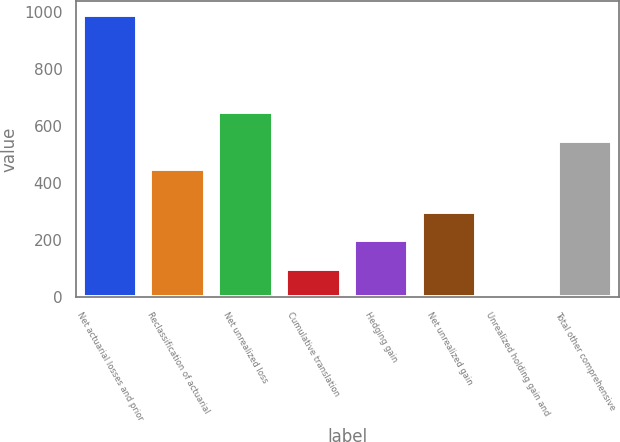Convert chart to OTSL. <chart><loc_0><loc_0><loc_500><loc_500><bar_chart><fcel>Net actuarial losses and prior<fcel>Reclassification of actuarial<fcel>Net unrealized loss<fcel>Cumulative translation<fcel>Hedging gain<fcel>Net unrealized gain<fcel>Unrealized holding gain and<fcel>Total other comprehensive<nl><fcel>989<fcel>450<fcel>647.4<fcel>100.7<fcel>199.4<fcel>298.1<fcel>2<fcel>548.7<nl></chart> 